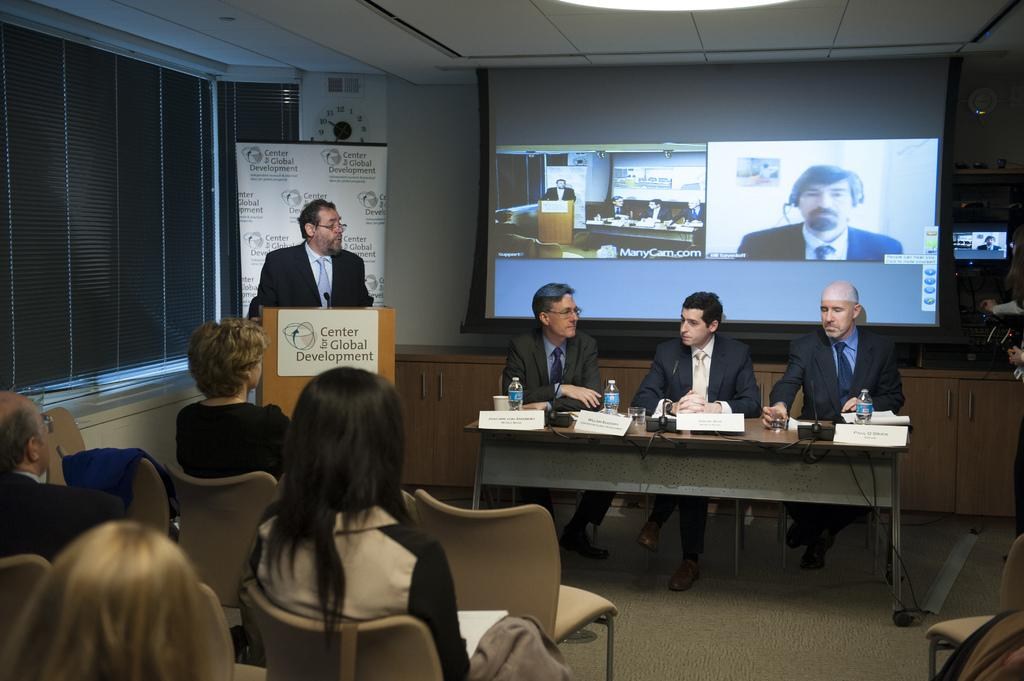What is the main subject of the image? The main subject of the image is a man standing and speaking. What are the other people in the image doing? There are three other people sitting beside the standing man at a table, and there are other people sitting and listening to the group. How many people are involved in the conversation or discussion? There are four people directly involved in the conversation or discussion, with the standing man and the three sitting beside him. What type of holiday is being celebrated in the image? There is no indication of a holiday being celebrated in the image. Can you see any fingers in the image? The image does not show any fingers; it focuses on the people and their positions. 